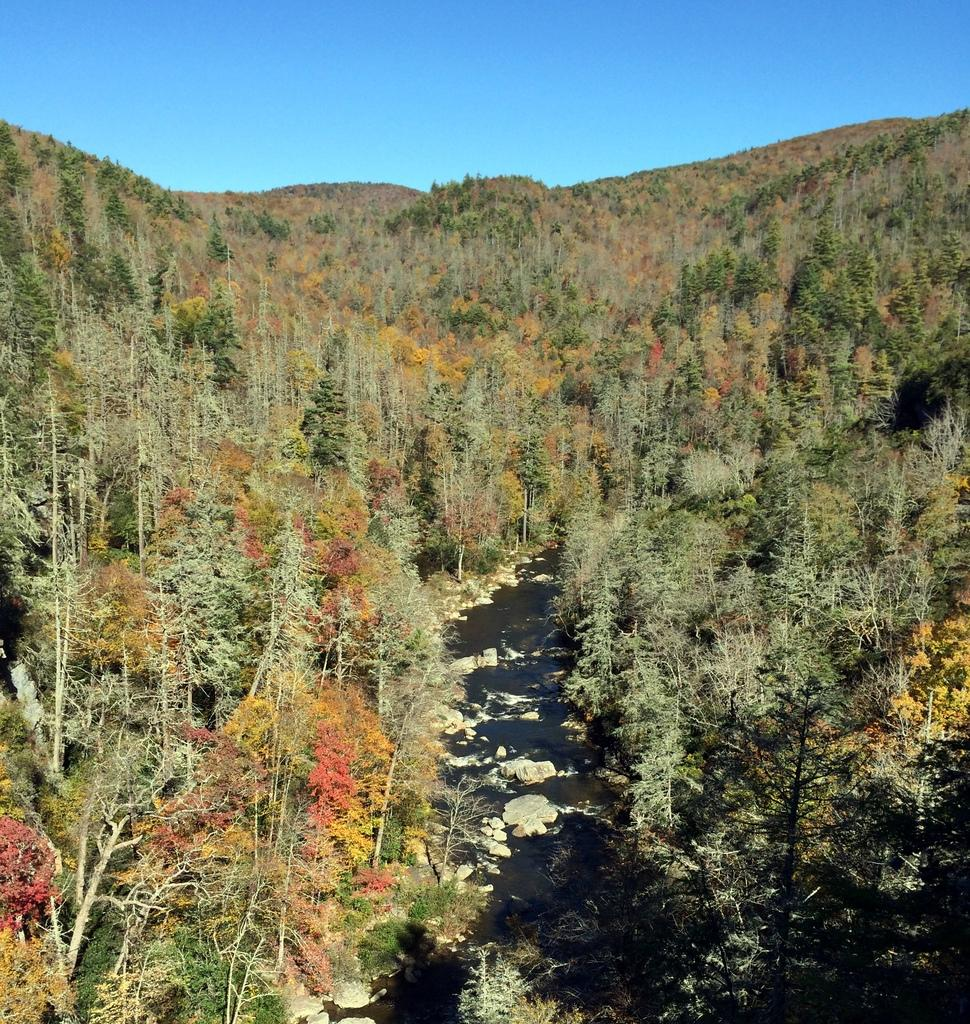What type of vegetation can be seen in the image? There are trees in the image. What is the path used for in the image? The path is between the trees, suggesting it is a path for walking or traveling. What part of the natural environment is visible in the image? The sky is visible in the image. What type of paper is being used to make the trees in the image? There is no paper present in the image; the trees are real trees in a natural environment. 